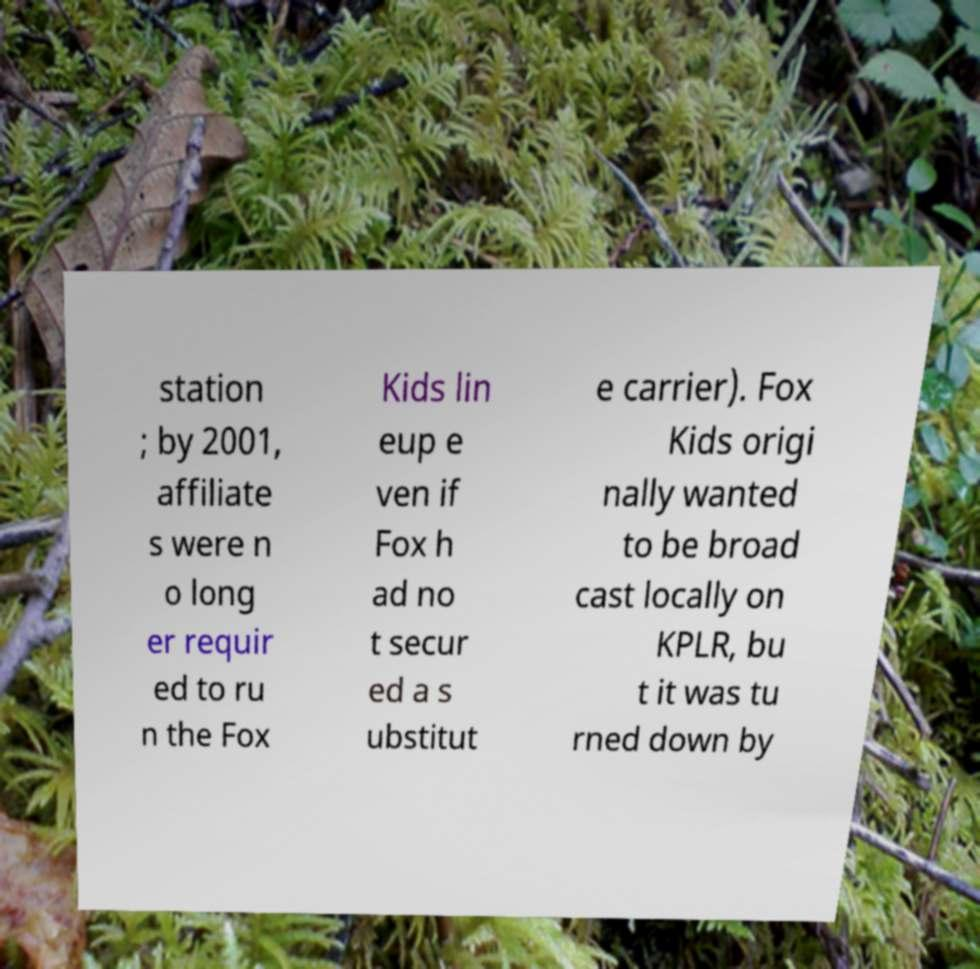Could you assist in decoding the text presented in this image and type it out clearly? station ; by 2001, affiliate s were n o long er requir ed to ru n the Fox Kids lin eup e ven if Fox h ad no t secur ed a s ubstitut e carrier). Fox Kids origi nally wanted to be broad cast locally on KPLR, bu t it was tu rned down by 